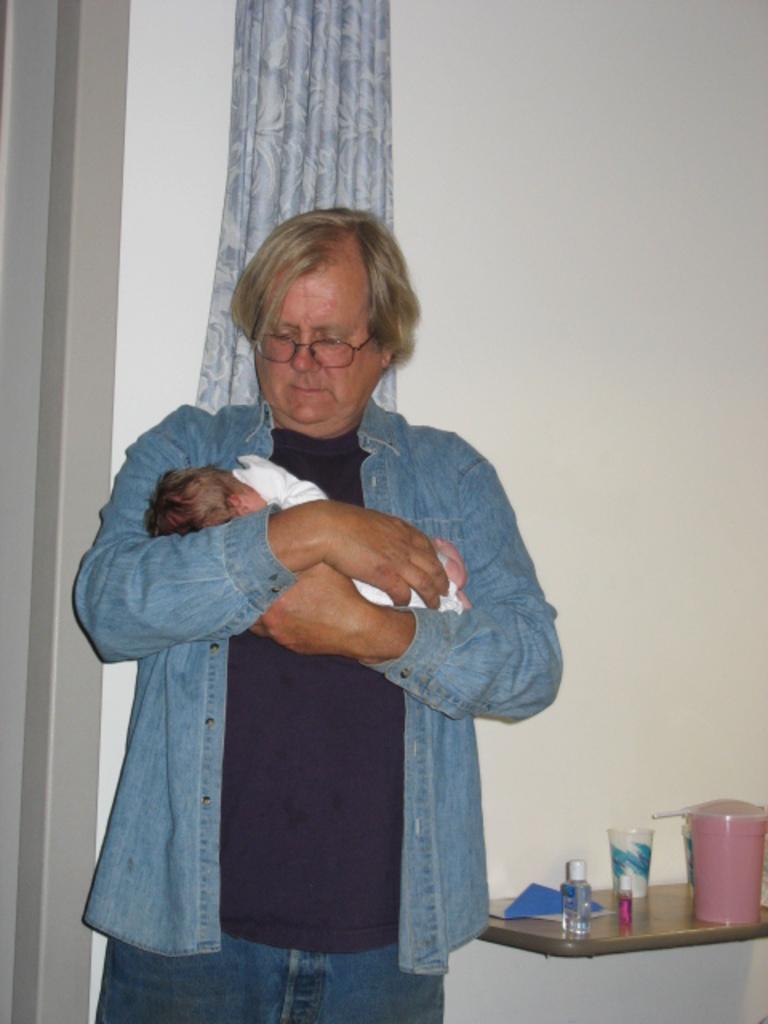Describe this image in one or two sentences. In this picture we can see a person, he is wearing a spectacles, he is carrying a child, here we can see a shelf, on this shelve we can see bottles, glass and some objects and in the background we can see a wall, curtain. 